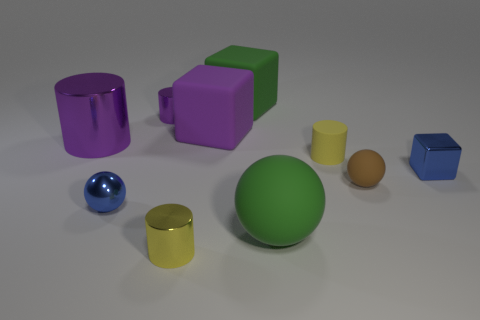Subtract all small blue cubes. How many cubes are left? 2 Subtract all large brown metallic blocks. Subtract all big purple blocks. How many objects are left? 9 Add 4 purple shiny cylinders. How many purple shiny cylinders are left? 6 Add 3 small brown matte balls. How many small brown matte balls exist? 4 Subtract all blue spheres. How many spheres are left? 2 Subtract 0 gray spheres. How many objects are left? 10 Subtract all blocks. How many objects are left? 7 Subtract 1 balls. How many balls are left? 2 Subtract all brown balls. Subtract all yellow cylinders. How many balls are left? 2 Subtract all cyan spheres. How many blue cubes are left? 1 